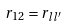Convert formula to latex. <formula><loc_0><loc_0><loc_500><loc_500>r _ { 1 2 } = r _ { { l } { l } ^ { \prime } }</formula> 